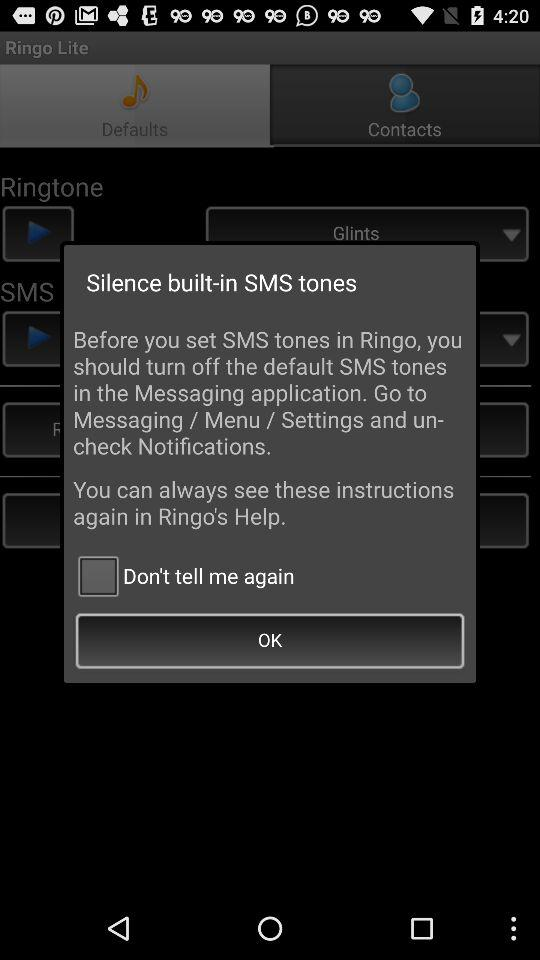What is the status of "Don't tell me again"? The status is "off". 